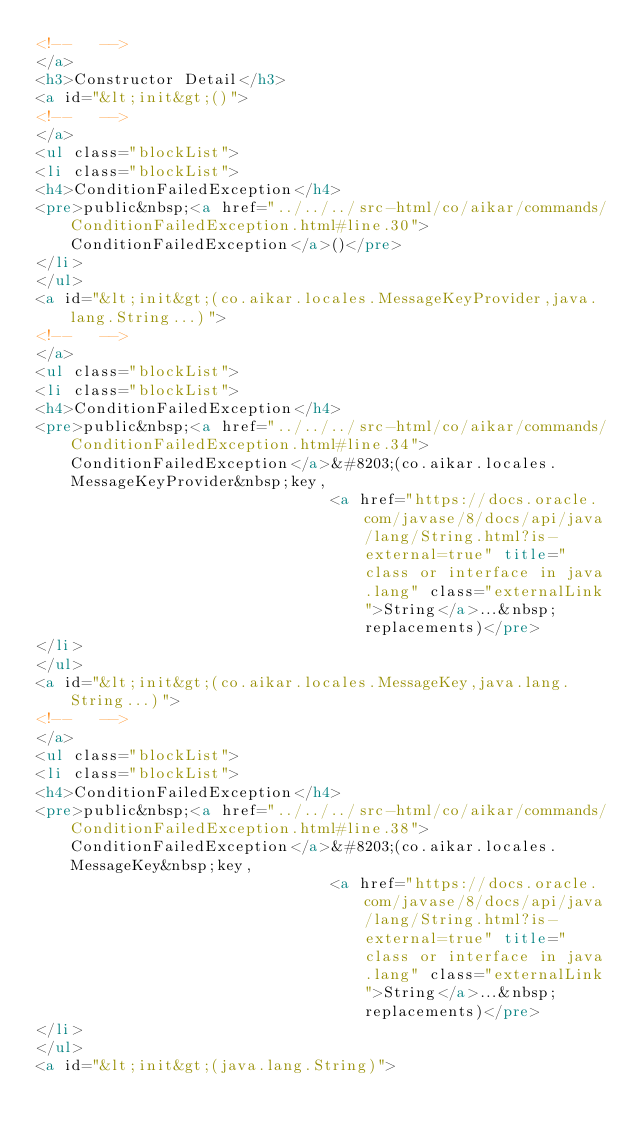<code> <loc_0><loc_0><loc_500><loc_500><_HTML_><!--   -->
</a>
<h3>Constructor Detail</h3>
<a id="&lt;init&gt;()">
<!--   -->
</a>
<ul class="blockList">
<li class="blockList">
<h4>ConditionFailedException</h4>
<pre>public&nbsp;<a href="../../../src-html/co/aikar/commands/ConditionFailedException.html#line.30">ConditionFailedException</a>()</pre>
</li>
</ul>
<a id="&lt;init&gt;(co.aikar.locales.MessageKeyProvider,java.lang.String...)">
<!--   -->
</a>
<ul class="blockList">
<li class="blockList">
<h4>ConditionFailedException</h4>
<pre>public&nbsp;<a href="../../../src-html/co/aikar/commands/ConditionFailedException.html#line.34">ConditionFailedException</a>&#8203;(co.aikar.locales.MessageKeyProvider&nbsp;key,
                                <a href="https://docs.oracle.com/javase/8/docs/api/java/lang/String.html?is-external=true" title="class or interface in java.lang" class="externalLink">String</a>...&nbsp;replacements)</pre>
</li>
</ul>
<a id="&lt;init&gt;(co.aikar.locales.MessageKey,java.lang.String...)">
<!--   -->
</a>
<ul class="blockList">
<li class="blockList">
<h4>ConditionFailedException</h4>
<pre>public&nbsp;<a href="../../../src-html/co/aikar/commands/ConditionFailedException.html#line.38">ConditionFailedException</a>&#8203;(co.aikar.locales.MessageKey&nbsp;key,
                                <a href="https://docs.oracle.com/javase/8/docs/api/java/lang/String.html?is-external=true" title="class or interface in java.lang" class="externalLink">String</a>...&nbsp;replacements)</pre>
</li>
</ul>
<a id="&lt;init&gt;(java.lang.String)"></code> 